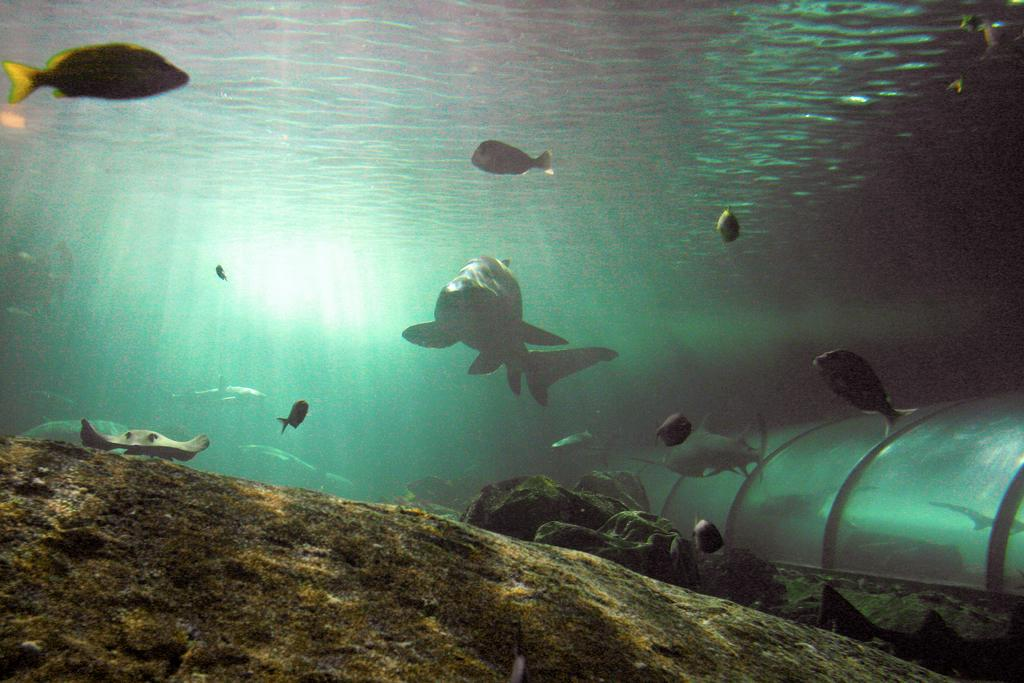What type of environment is shown in the image? The image depicts an underwater environment. What can be seen swimming in the water? There are fishes visible in the water. What type of badge is being worn by the fish in the image? There are no badges present in the image, as it depicts an underwater environment with fishes. 